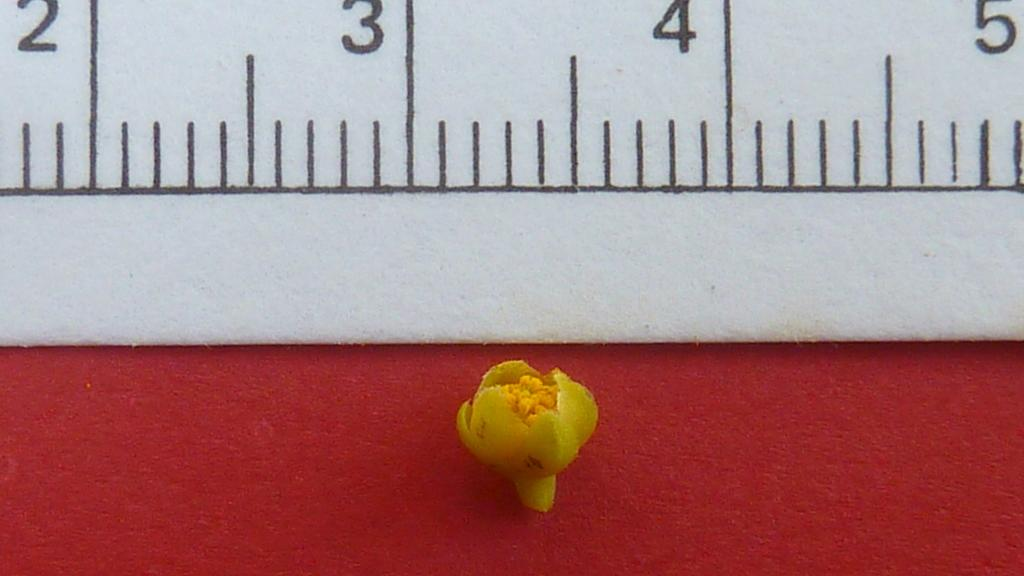What is the main object in the center of the image? There is an object in the center of the image that is yellow in color. What can be seen in the background of the image? There is a white color wall in the background of the image. Are there any markings or text on the wall in the background? Yes, there are numbers written on the wall in the background. What type of game is being played by the daughter in the image? There is no daughter or game present in the image. How many beans are visible on the yellow object in the image? There are no beans visible on the yellow object in the image. 